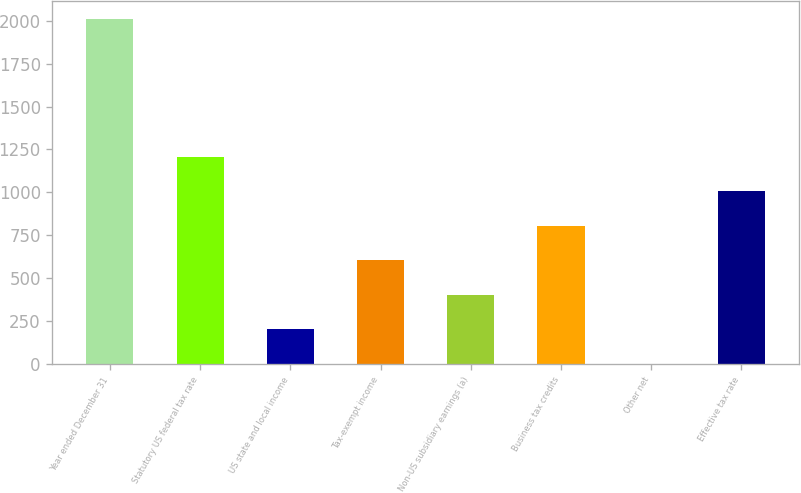Convert chart to OTSL. <chart><loc_0><loc_0><loc_500><loc_500><bar_chart><fcel>Year ended December 31<fcel>Statutory US federal tax rate<fcel>US state and local income<fcel>Tax-exempt income<fcel>Non-US subsidiary earnings (a)<fcel>Business tax credits<fcel>Other net<fcel>Effective tax rate<nl><fcel>2012<fcel>1207.48<fcel>201.83<fcel>604.09<fcel>402.96<fcel>805.22<fcel>0.7<fcel>1006.35<nl></chart> 